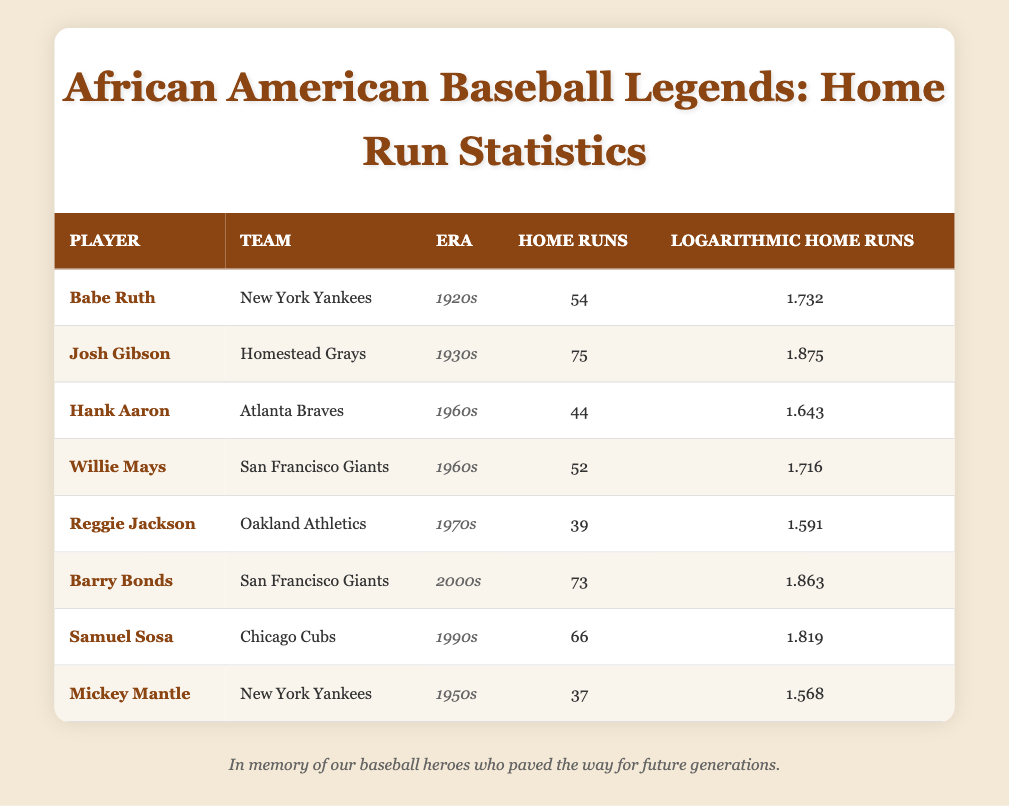What is the highest number of home runs hit by a player in the table? The player with the highest number of home runs is Josh Gibson, who hit 75 home runs. This can be found by scanning the "Home Runs" column and identifying the maximum value.
Answer: 75 Which era has the player with the lowest home run total? The player with the lowest home run total is Mickey Mantle, who hit 37 home runs in the 1950s. By checking the "Home Runs" column and comparing the values, Mantle's total is the smallest.
Answer: 1950s What is the sum of home runs by players from the 1960s? The home runs by players from the 1960s are Hank Aaron (44) and Willie Mays (52). Adding these gives 44 + 52 = 96.
Answer: 96 Did Barry Bonds hit more home runs than Josh Gibson? No, Barry Bonds hit 73 home runs, while Josh Gibson hit more with 75. Comparing the two values in the "Home Runs" column, we find that 73 is less than 75.
Answer: No What is the average number of home runs hit by players in the 2000s and 1990s combined? Barry Bonds hit 73 home runs in the 2000s and Samuel Sosa hit 66 in the 1990s. To find the average, first calculate the sum: 73 + 66 = 139. Then divide by the number of players, which is 2. So 139/2 = 69.5.
Answer: 69.5 Who has a higher logarithmic home run value, Samuel Sosa or Reggie Jackson? Samuel Sosa has a logarithmic home run value of 1.819, while Reggie Jackson has 1.591. Comparing the two values shows that 1.819 is greater than 1.591.
Answer: Samuel Sosa How many players hit more than 50 home runs? The players who hit more than 50 home runs are Josh Gibson (75), Barry Bonds (73), and Willie Mays (52). We can count these players in the table, resulting in a total of 3.
Answer: 3 What is the difference in home runs between Babe Ruth and Mickey Mantle? Babe Ruth hit 54 home runs, and Mickey Mantle hit 37 home runs. The difference is calculated by subtracting 37 from 54, resulting in 54 - 37 = 17.
Answer: 17 